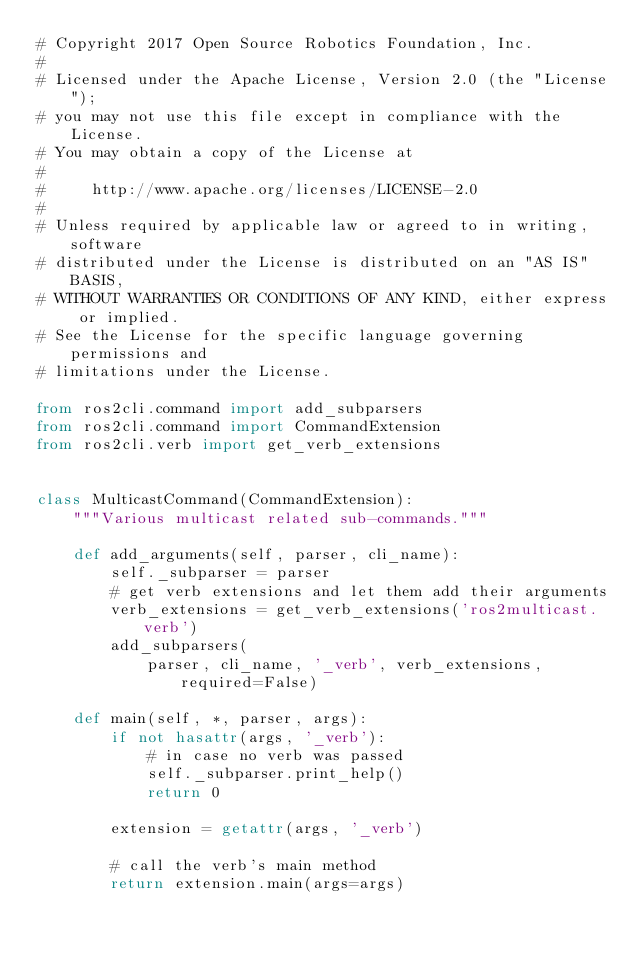<code> <loc_0><loc_0><loc_500><loc_500><_Python_># Copyright 2017 Open Source Robotics Foundation, Inc.
#
# Licensed under the Apache License, Version 2.0 (the "License");
# you may not use this file except in compliance with the License.
# You may obtain a copy of the License at
#
#     http://www.apache.org/licenses/LICENSE-2.0
#
# Unless required by applicable law or agreed to in writing, software
# distributed under the License is distributed on an "AS IS" BASIS,
# WITHOUT WARRANTIES OR CONDITIONS OF ANY KIND, either express or implied.
# See the License for the specific language governing permissions and
# limitations under the License.

from ros2cli.command import add_subparsers
from ros2cli.command import CommandExtension
from ros2cli.verb import get_verb_extensions


class MulticastCommand(CommandExtension):
    """Various multicast related sub-commands."""

    def add_arguments(self, parser, cli_name):
        self._subparser = parser
        # get verb extensions and let them add their arguments
        verb_extensions = get_verb_extensions('ros2multicast.verb')
        add_subparsers(
            parser, cli_name, '_verb', verb_extensions, required=False)

    def main(self, *, parser, args):
        if not hasattr(args, '_verb'):
            # in case no verb was passed
            self._subparser.print_help()
            return 0

        extension = getattr(args, '_verb')

        # call the verb's main method
        return extension.main(args=args)
</code> 